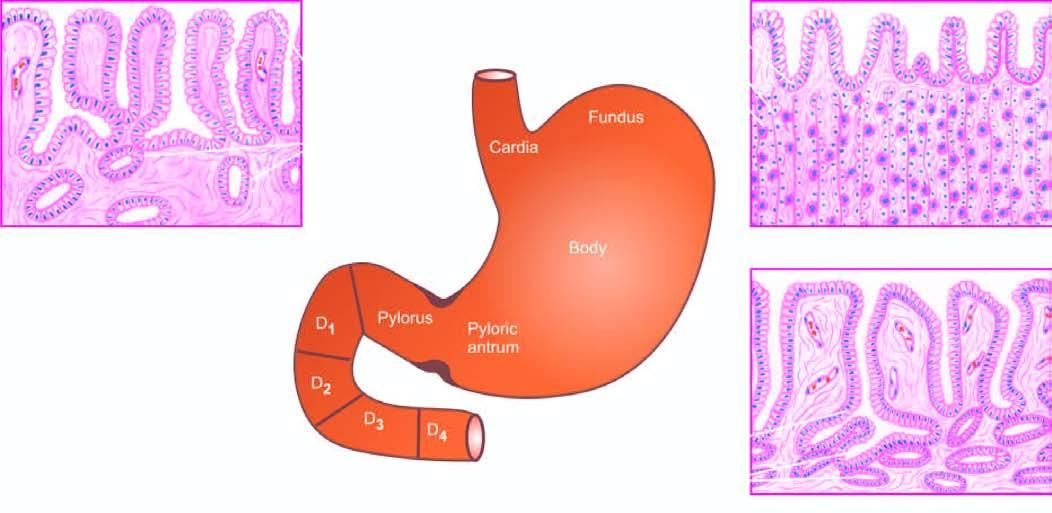re natomical subdivisions of the stomach correlated with histological appearance of gastric mucosa in different regions?
Answer the question using a single word or phrase. Yes 